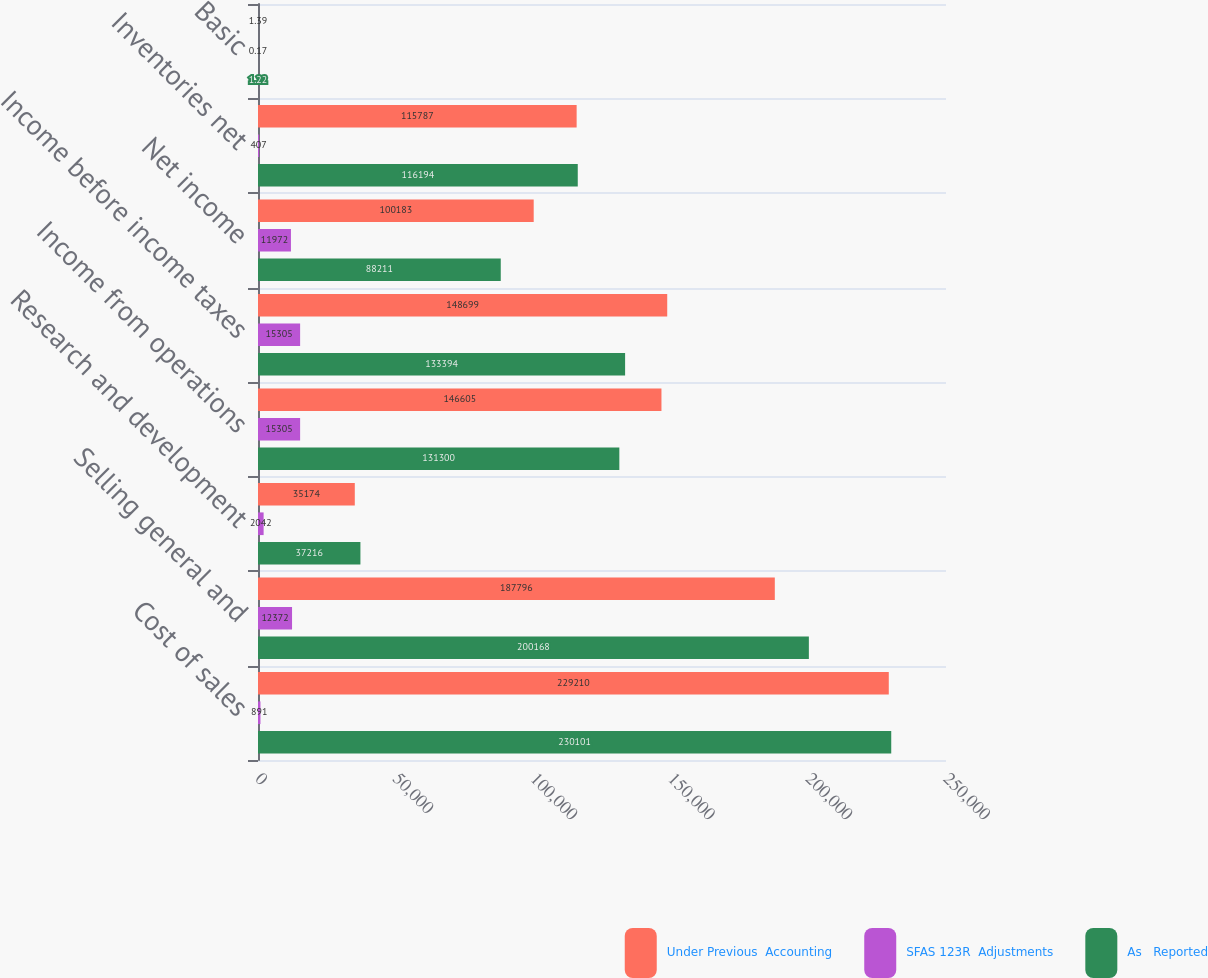<chart> <loc_0><loc_0><loc_500><loc_500><stacked_bar_chart><ecel><fcel>Cost of sales<fcel>Selling general and<fcel>Research and development<fcel>Income from operations<fcel>Income before income taxes<fcel>Net income<fcel>Inventories net<fcel>Basic<nl><fcel>Under Previous  Accounting<fcel>229210<fcel>187796<fcel>35174<fcel>146605<fcel>148699<fcel>100183<fcel>115787<fcel>1.39<nl><fcel>SFAS 123R  Adjustments<fcel>891<fcel>12372<fcel>2042<fcel>15305<fcel>15305<fcel>11972<fcel>407<fcel>0.17<nl><fcel>As   Reported<fcel>230101<fcel>200168<fcel>37216<fcel>131300<fcel>133394<fcel>88211<fcel>116194<fcel>1.22<nl></chart> 